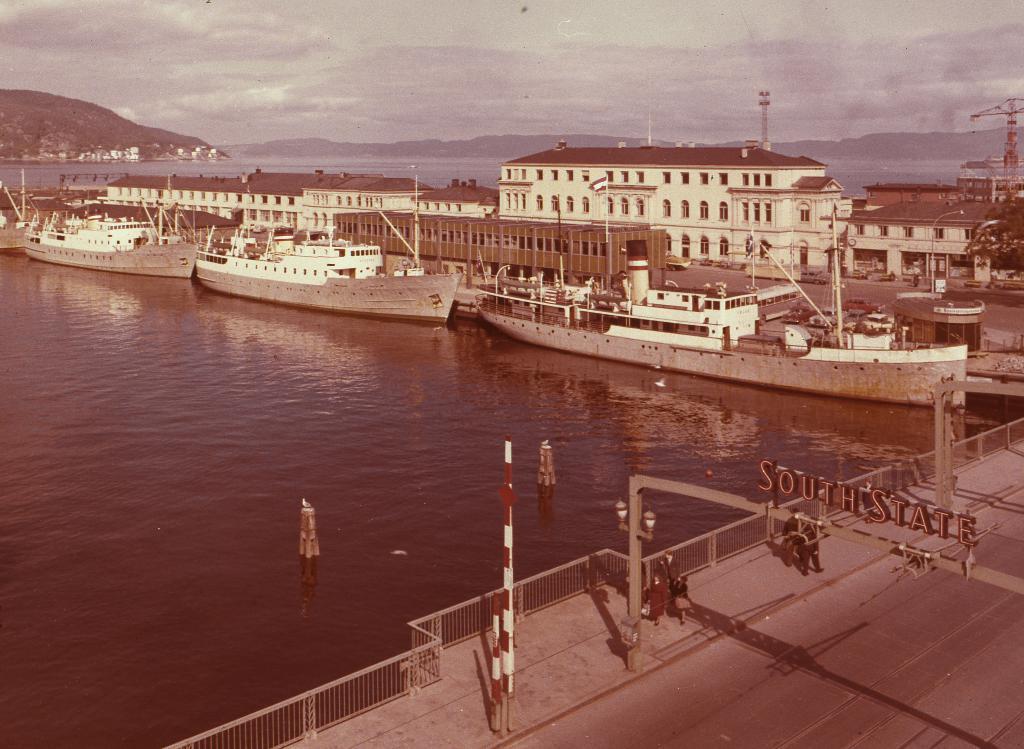Please provide a concise description of this image. In this image there are a few people standing on the road, in front of the road there is a river and there are few ships on the river. At the center of the image there are buildings. In the background there are mountains and a sky. 